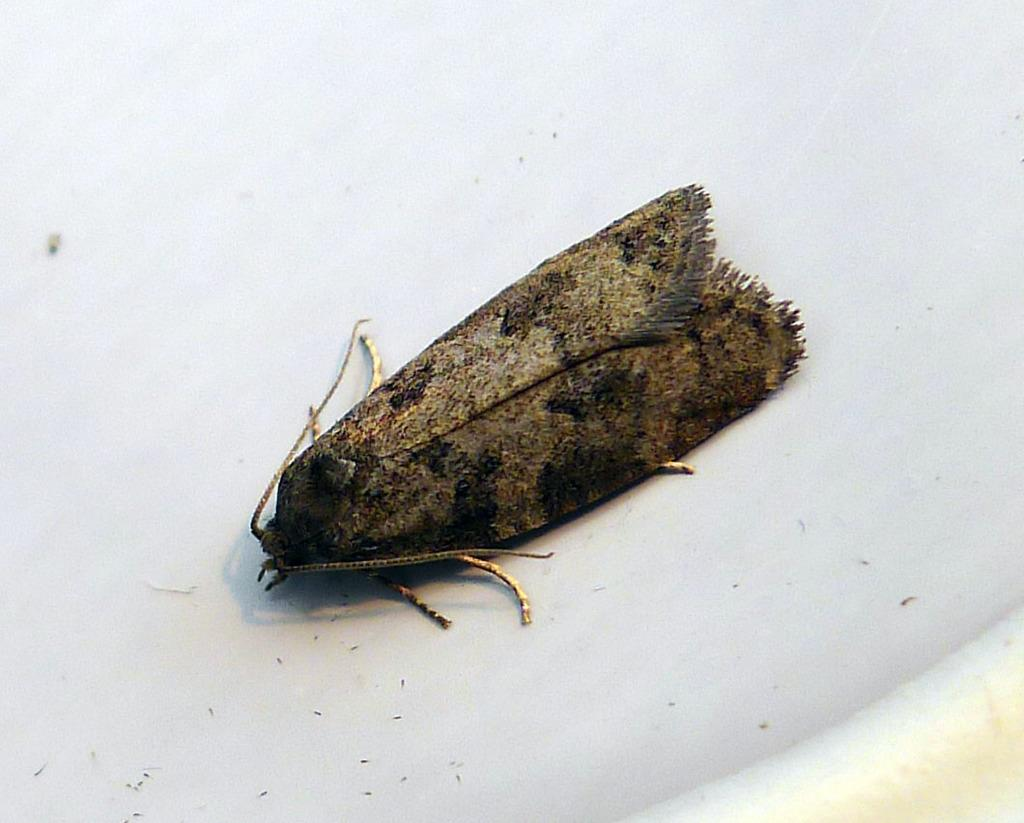What type of creature is in the image? There is an insect in the image. Can you identify the specific type of insect? The insect is a Brown House Moth. What is the background or surface on which the insect is located? The insect is on a white surface. What type of wood is the insect using to cook in the image? There is no wood or cooking activity present in the image; it features a Brown House Moth on a white surface. 